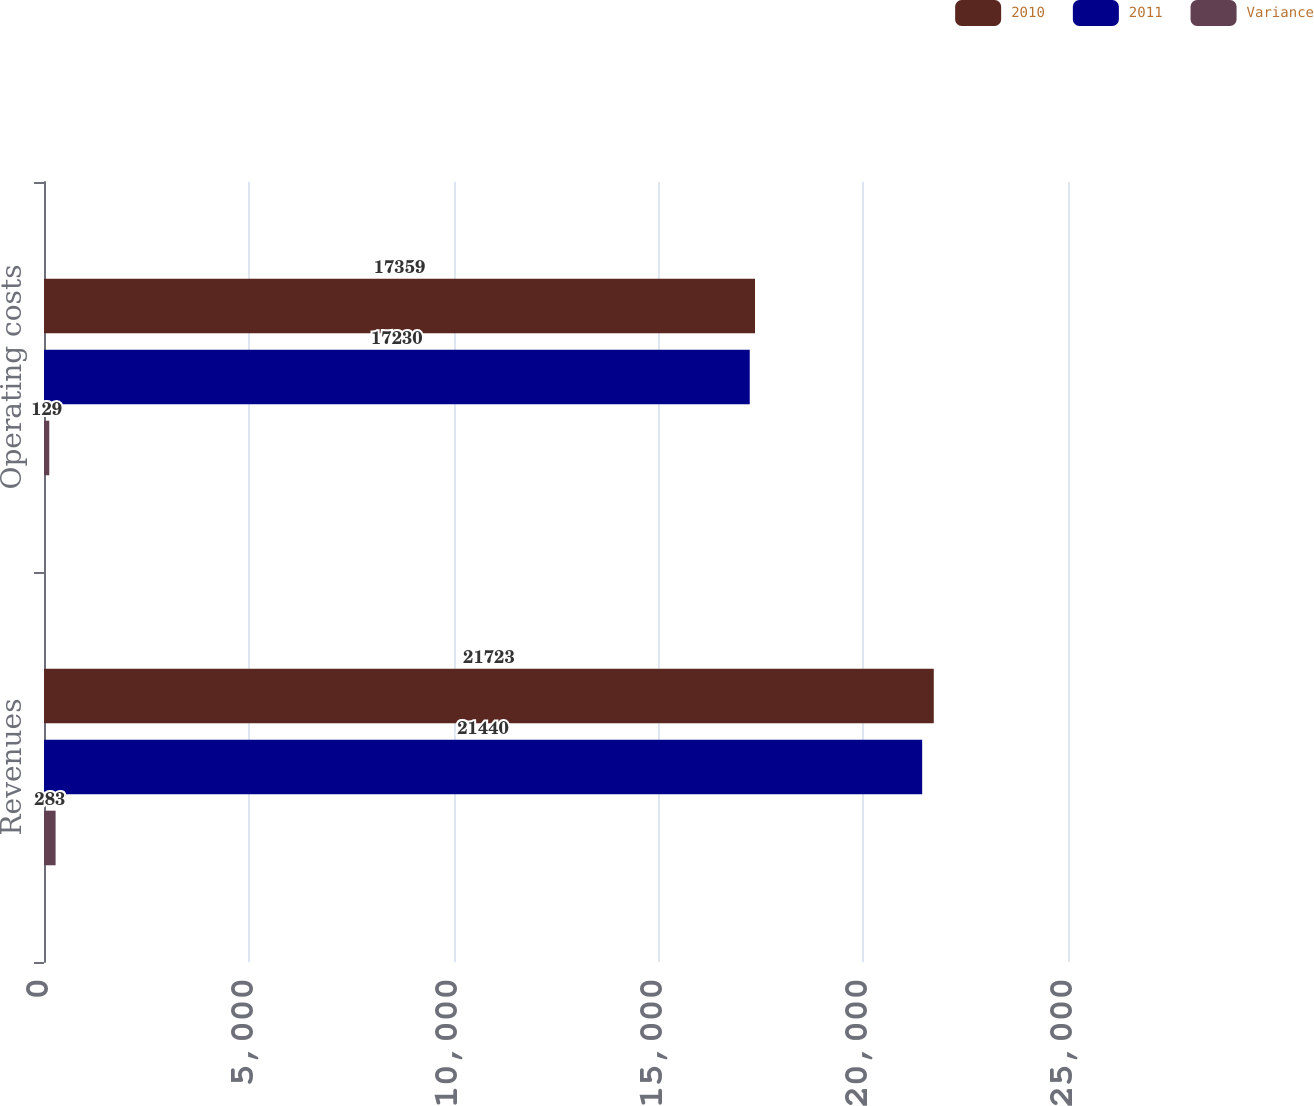Convert chart. <chart><loc_0><loc_0><loc_500><loc_500><stacked_bar_chart><ecel><fcel>Revenues<fcel>Operating costs<nl><fcel>2010<fcel>21723<fcel>17359<nl><fcel>2011<fcel>21440<fcel>17230<nl><fcel>Variance<fcel>283<fcel>129<nl></chart> 